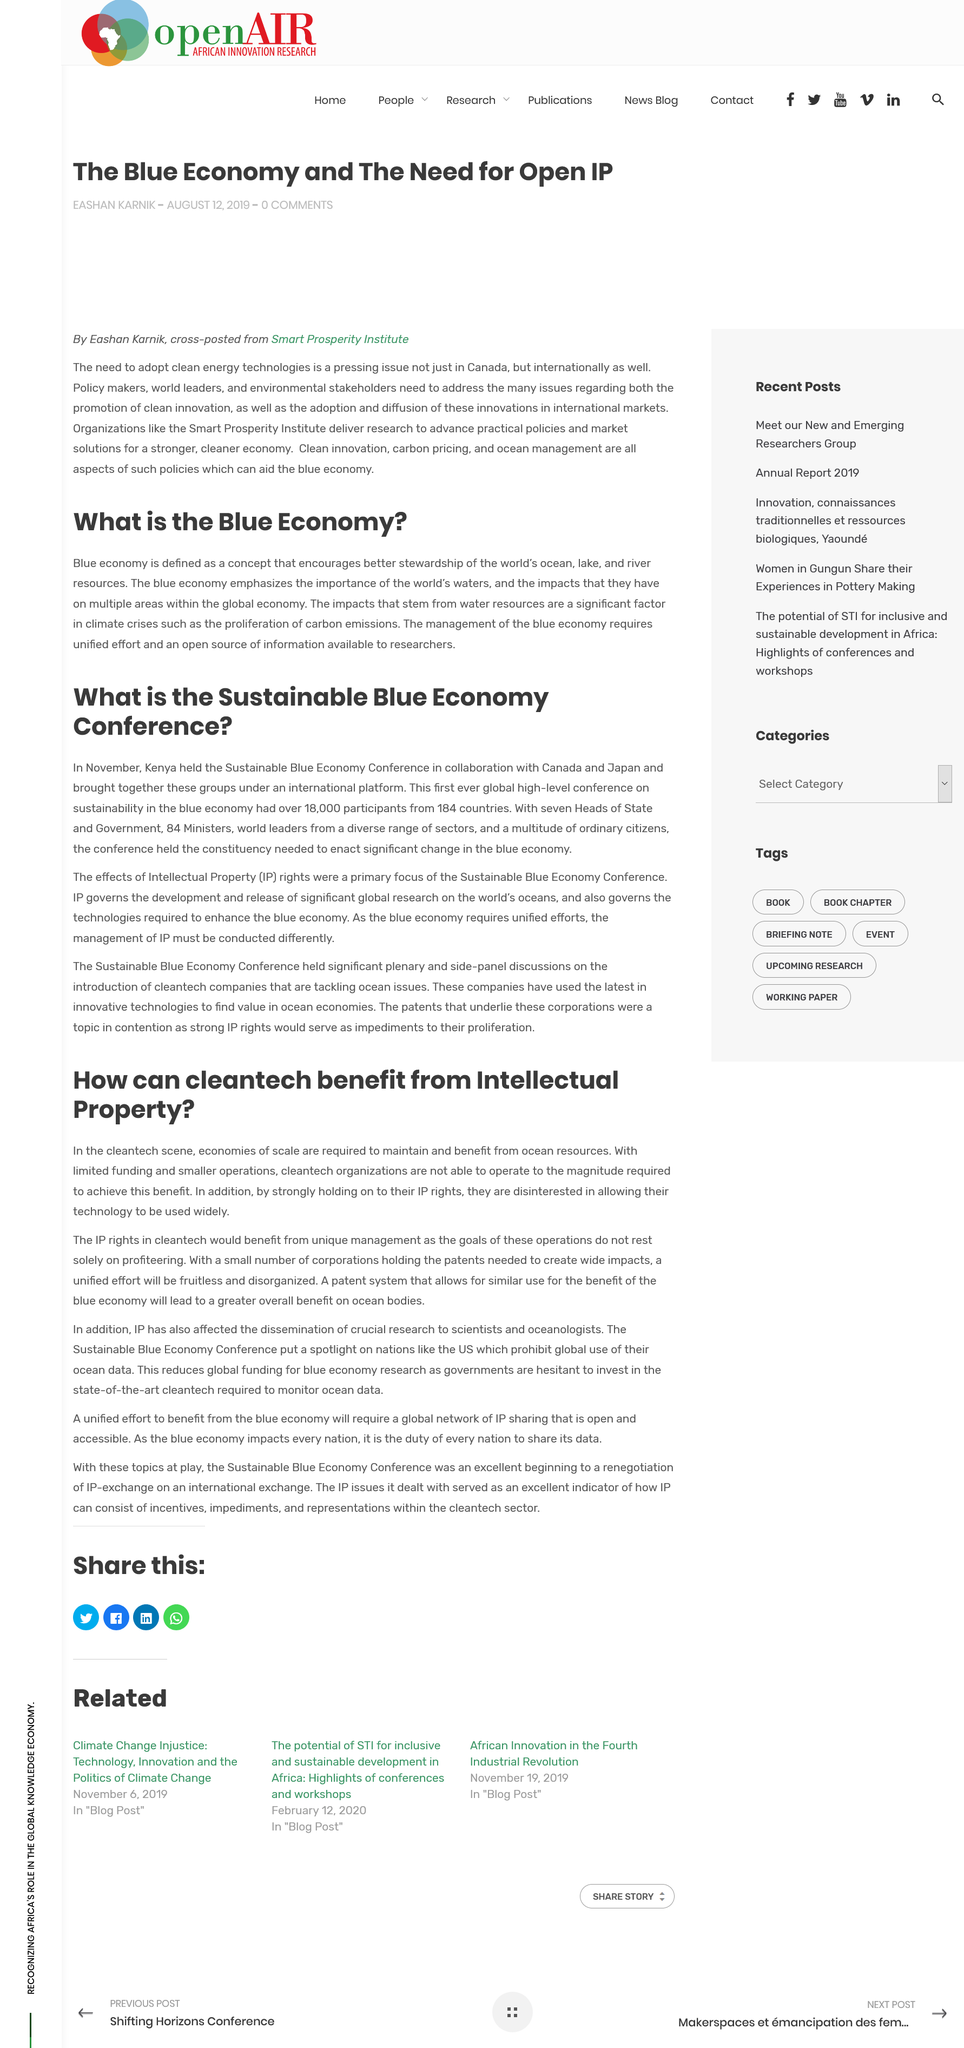Indicate a few pertinent items in this graphic. The Smart Prosperity Institute delivers research to advance practical policies and market solutions that promote economic growth and sustainability. Cleantech companies would benefit from unique intellectual property rights, which would provide them with a competitive advantage in the marketplace. The Sustainable Blue Economy Conference primarily focused on the effects of Intellectual Property. It is recommended that cleantech economies utilize ocean resources as a valuable resource. It is not the case that cleantech operations are interested in allowing their technology to be used widely. 